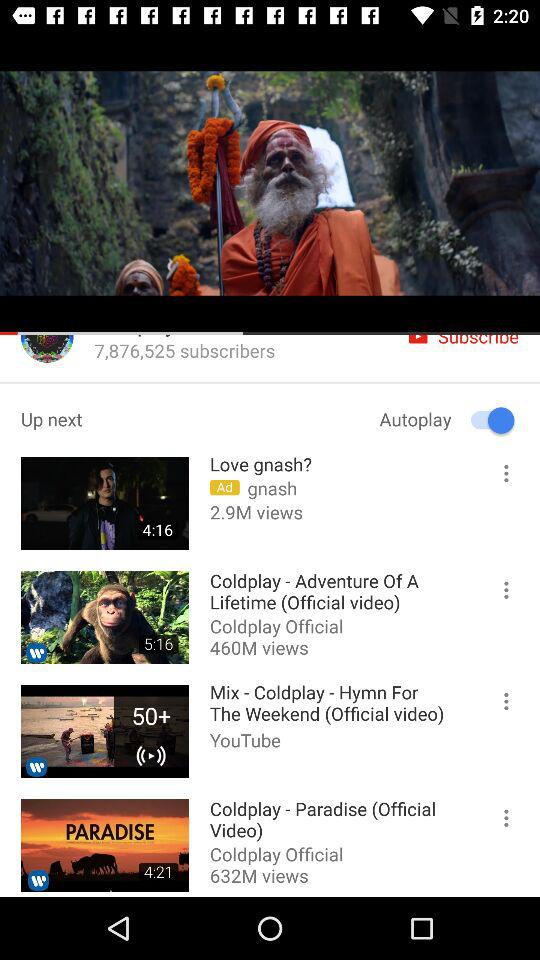What is the total number of views on "Love gnash?"? The total number of views on "Love gnash?" is 2.9 million. 